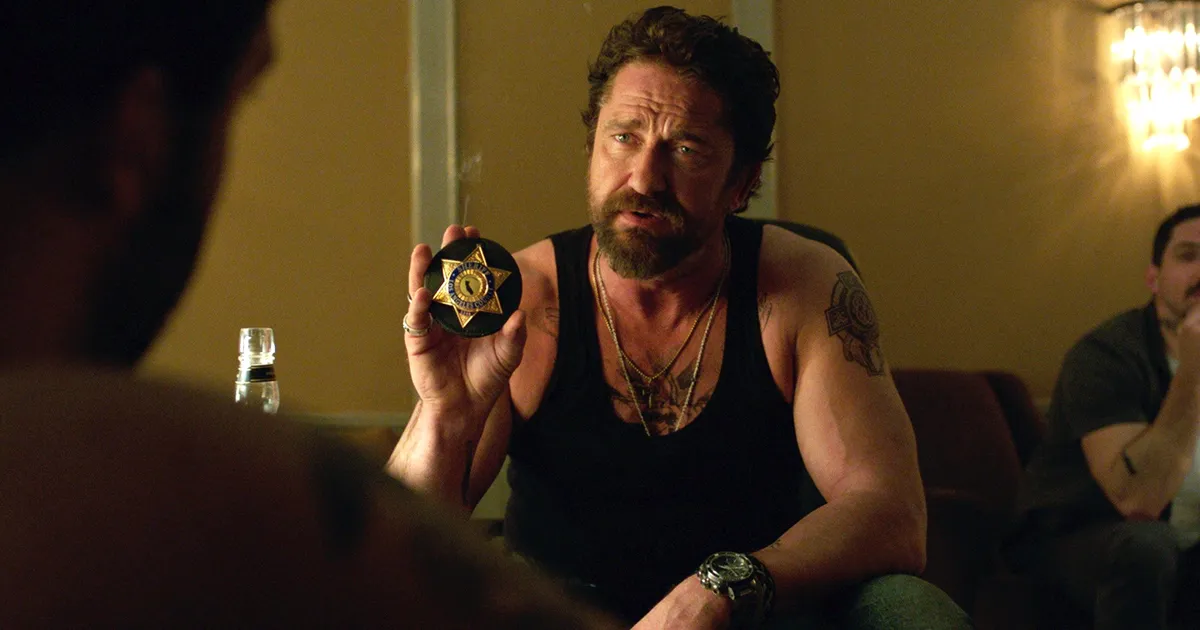What do you think is going on in this snapshot? This image depicts a dramatic scene likely from a film. The central character, a bearded man with a rugged appearance, is holding up a police badge, suggesting he is portraying a law enforcement officer perhaps in the midst of a tense situation. He's dressed casually with a tattoo visible on his arm, adding a tough, gritty feel to his persona. The dimly lit room and his serious expression evoke a sense of urgency or confrontation. Two other individuals appear in the background, contributing to the scene's layered complexity. One is seated on a couch, seemingly relaxed yet attentive, while the other stands by the table, engaging indirectly. This setting might depict a crucial, possibly confrontational moment where the main character is asserting his authority. 